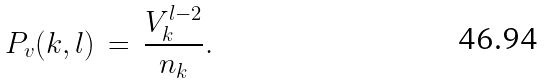<formula> <loc_0><loc_0><loc_500><loc_500>P _ { v } ( k , l ) \, = \, \frac { V _ { k } ^ { l - 2 } } { n _ { k } } .</formula> 